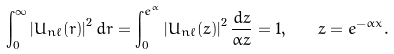<formula> <loc_0><loc_0><loc_500><loc_500>\int _ { 0 } ^ { \infty } \left | U _ { n \ell } ( r ) \right | ^ { 2 } d r = \int _ { 0 } ^ { e ^ { \alpha } } \left | U _ { n \ell } ( z ) \right | ^ { 2 } \frac { d z } { \alpha z } = 1 , \quad z = e ^ { - \alpha x } .</formula> 